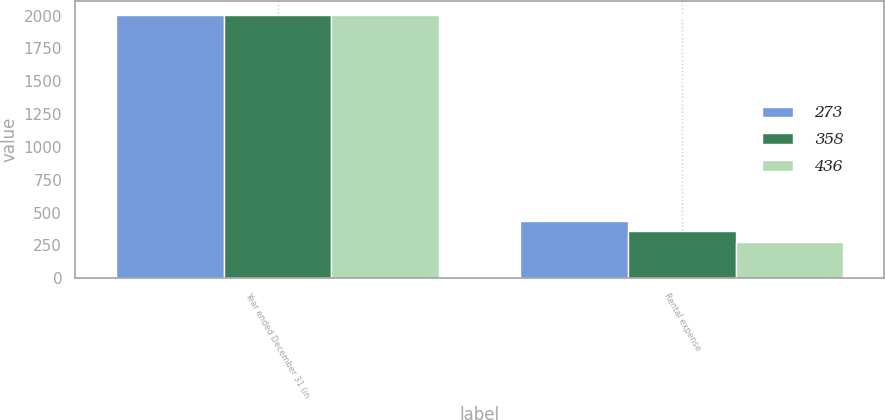Convert chart. <chart><loc_0><loc_0><loc_500><loc_500><stacked_bar_chart><ecel><fcel>Year ended December 31 (in<fcel>Rental expense<nl><fcel>273<fcel>2008<fcel>436<nl><fcel>358<fcel>2007<fcel>358<nl><fcel>436<fcel>2006<fcel>273<nl></chart> 